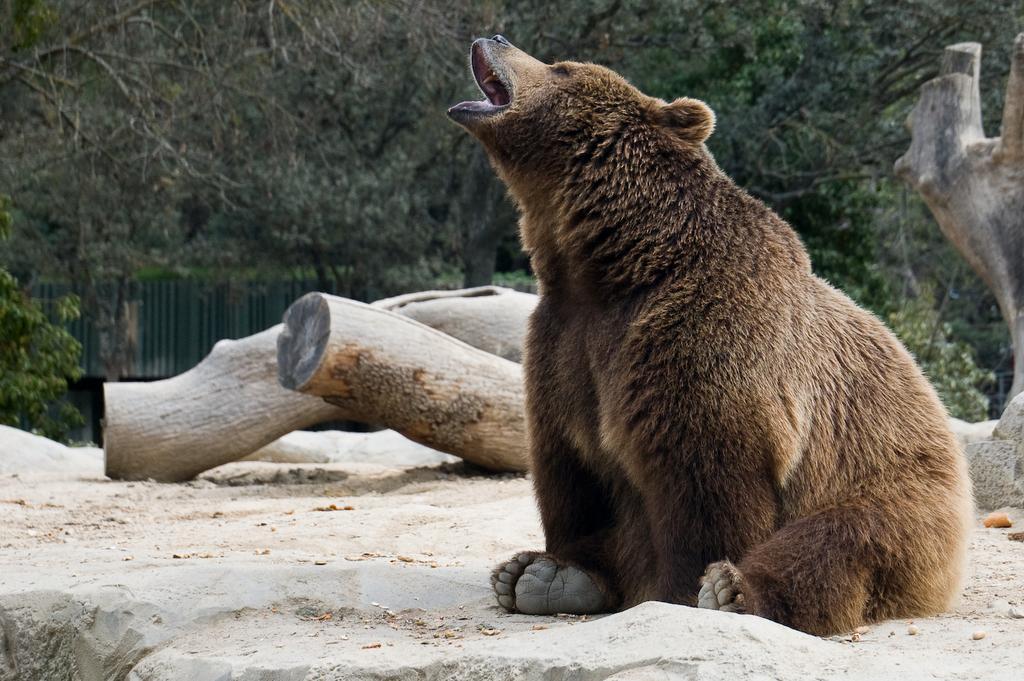In one or two sentences, can you explain what this image depicts? In this image, we can see an animal. We can see the ground with some objects like wood. There are a few trees. We can also see the fence. 